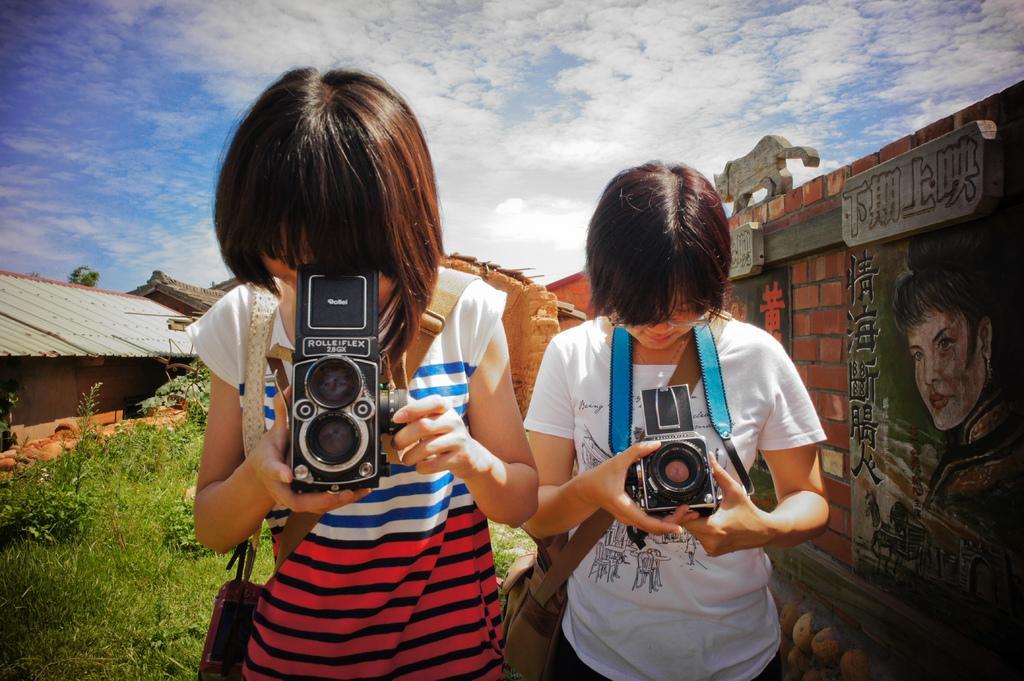In one or two sentences, can you explain what this image depicts? In the image we can see there are two people who are holding camera in their hands and behind them there is a clear sky on the top and the ground is filled with grass. 